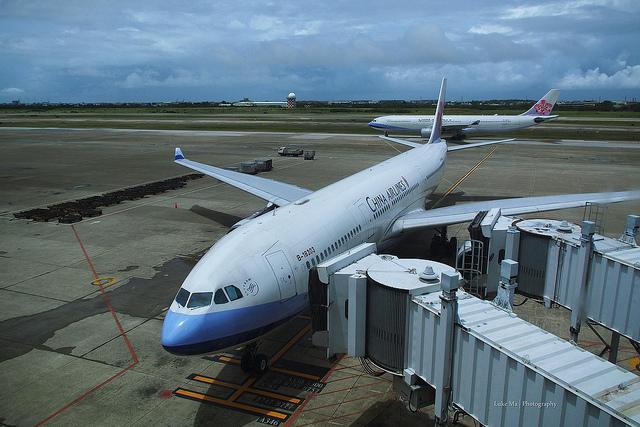Is this a commercial plane?
Be succinct. Yes. Is the plane in the background also on the tarmac?
Give a very brief answer. Yes. Where is the plane?
Write a very short answer. Airport. 